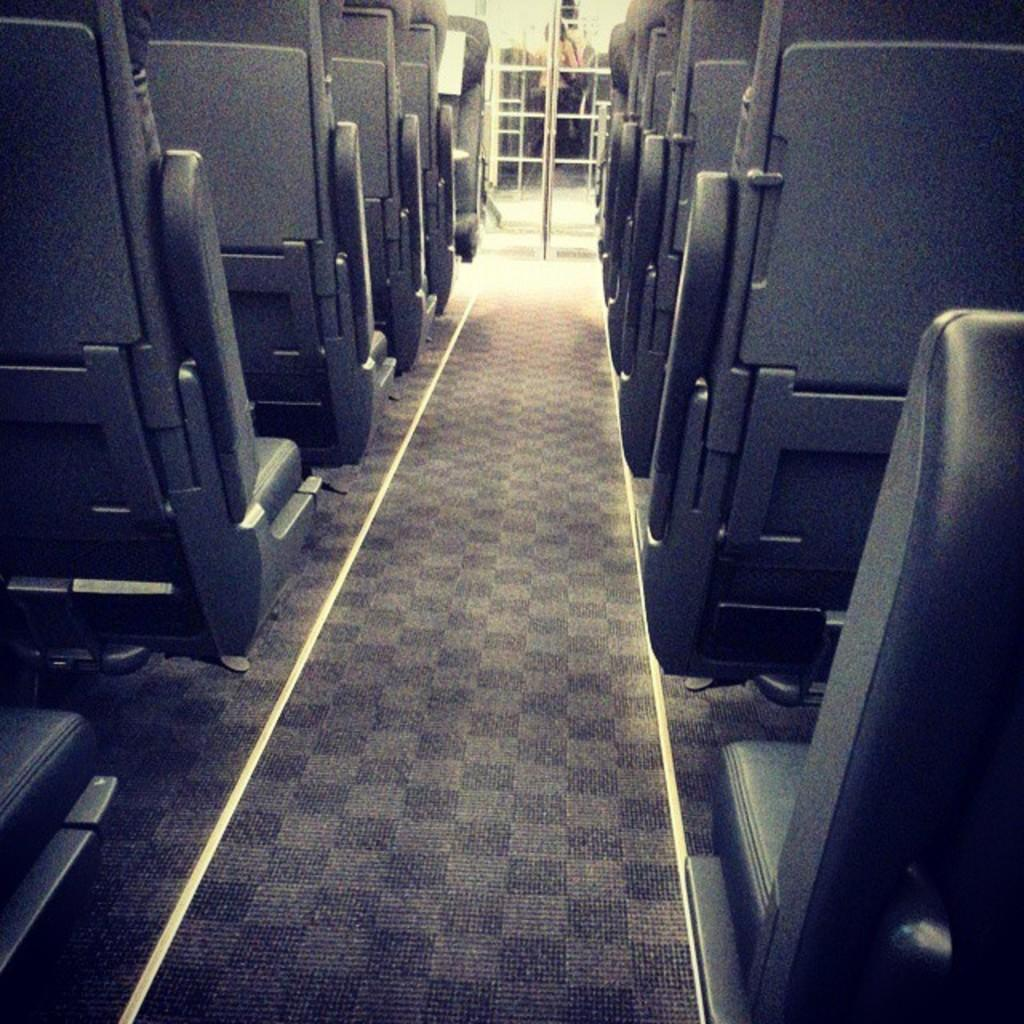What can be seen on the left and right sides of the image? There are groups of seats on the left and right sides of the image. What structures are visible at the top of the image? There are poles visible at the top of the image. Can you describe the person in the image? A person is standing in the image. How many eyes does the train have in the image? There is no train present in the image, so it is not possible to determine the number of eyes it might have. 